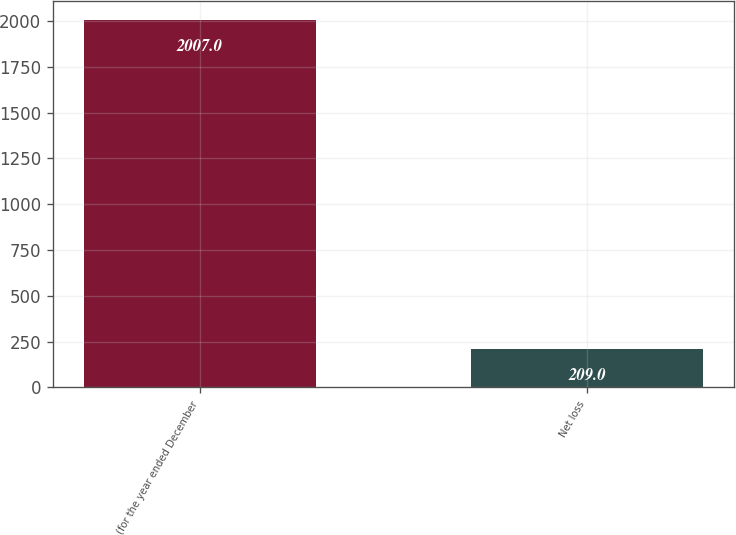<chart> <loc_0><loc_0><loc_500><loc_500><bar_chart><fcel>(for the year ended December<fcel>Net loss<nl><fcel>2007<fcel>209<nl></chart> 